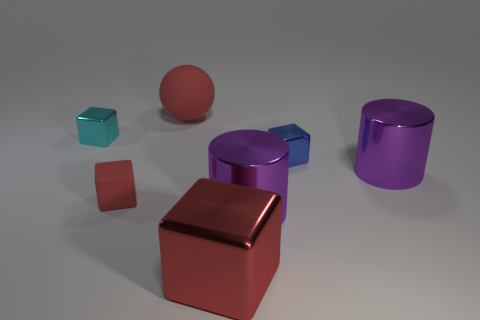There is a shiny block on the right side of the big red thing that is to the right of the large rubber ball; what size is it?
Your answer should be compact. Small. There is a matte block that is the same color as the large matte sphere; what size is it?
Make the answer very short. Small. What number of other objects are there of the same size as the red rubber block?
Your answer should be very brief. 2. What number of metal blocks are there?
Provide a succinct answer. 3. Is the size of the red metal block the same as the cyan object?
Ensure brevity in your answer.  No. How many other objects are there of the same shape as the large rubber thing?
Provide a short and direct response. 0. What is the large object that is behind the tiny cyan metallic cube that is on the left side of the matte ball made of?
Make the answer very short. Rubber. Are there any big blocks behind the blue metallic cube?
Make the answer very short. No. Do the blue block and the purple object that is left of the blue object have the same size?
Your answer should be compact. No. There is another blue object that is the same shape as the small matte object; what size is it?
Ensure brevity in your answer.  Small. 